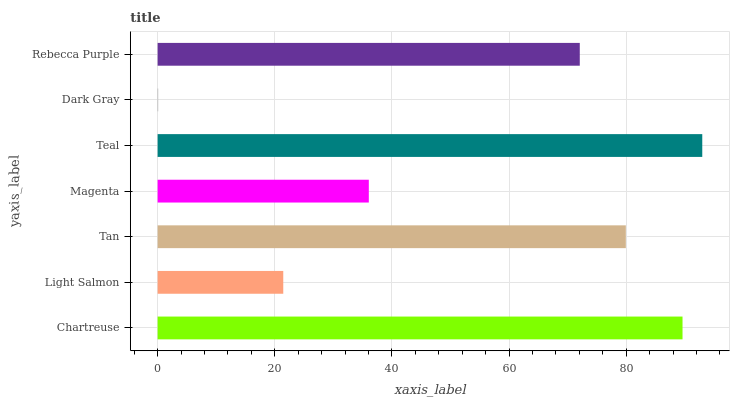Is Dark Gray the minimum?
Answer yes or no. Yes. Is Teal the maximum?
Answer yes or no. Yes. Is Light Salmon the minimum?
Answer yes or no. No. Is Light Salmon the maximum?
Answer yes or no. No. Is Chartreuse greater than Light Salmon?
Answer yes or no. Yes. Is Light Salmon less than Chartreuse?
Answer yes or no. Yes. Is Light Salmon greater than Chartreuse?
Answer yes or no. No. Is Chartreuse less than Light Salmon?
Answer yes or no. No. Is Rebecca Purple the high median?
Answer yes or no. Yes. Is Rebecca Purple the low median?
Answer yes or no. Yes. Is Dark Gray the high median?
Answer yes or no. No. Is Dark Gray the low median?
Answer yes or no. No. 